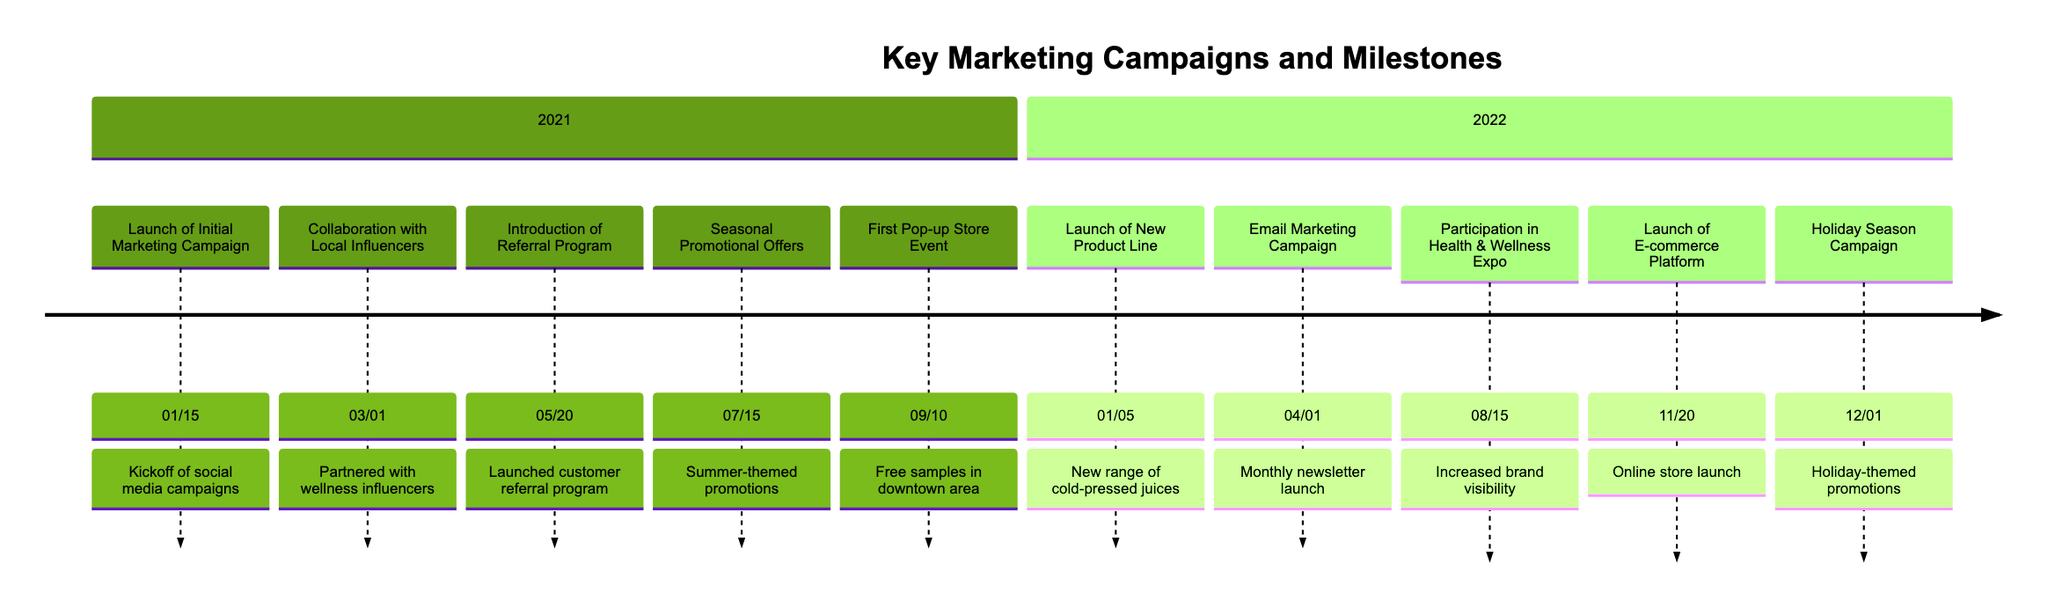What is the date of the collaboration with local influencers? The timeline shows that the collaboration with local influencers took place on March 1, 2021.
Answer: March 1, 2021 How many marketing campaigns were launched in 2021? By counting the campaigns listed in the 2021 section of the timeline, we find five campaigns: the Initial Marketing Campaign, Collaboration with Local Influencers, Introduction of Referral Program, Seasonal Promotional Offers, and First Pop-up Store Event.
Answer: 5 Which event occurred first in 2022? The timeline indicates that the Launch of New Product Line occurred on January 5, 2022, which is earlier than the other 2022 events, making it the first.
Answer: Launch of New Product Line What type of promotions were used during the summer of 2021? The information states that seasonal promotional offers implemented summer-themed promotions and discounts to boost sales during peak months.
Answer: Summer-themed promotions Which campaign directly followed the launch of the e-commerce platform? The Holiday Season Campaign occurred on December 1, 2022, right after the e-commerce platform was launched on November 20, 2022.
Answer: Holiday Season Campaign What was the main goal of the Participation in Health & Wellness Expo? The timeline describes the goal as increasing brand visibility and connecting with health-conscious consumers, which indicates a focus on outreach and awareness.
Answer: Increase brand visibility How long after the initial marketing campaign was the referral program introduced? The initial marketing campaign launched on January 15, 2021, and the referral program was introduced on May 20, 2021. Calculating the time difference results in approximately 4 months and 5 days.
Answer: 4 months and 5 days What was the main feature of the email marketing campaign launched in April 2022? The timeline specifies that the email marketing campaign was a monthly newsletter sharing health tips, promoting new products, and offering special discounts.
Answer: Monthly newsletter Which campaign was specifically aimed at the holiday season? The timeline states that the Holiday Season Campaign was rolled out to capitalize on the festive season by offering holiday-themed promotions, including gift packs and limited-edition flavors.
Answer: Holiday Season Campaign 